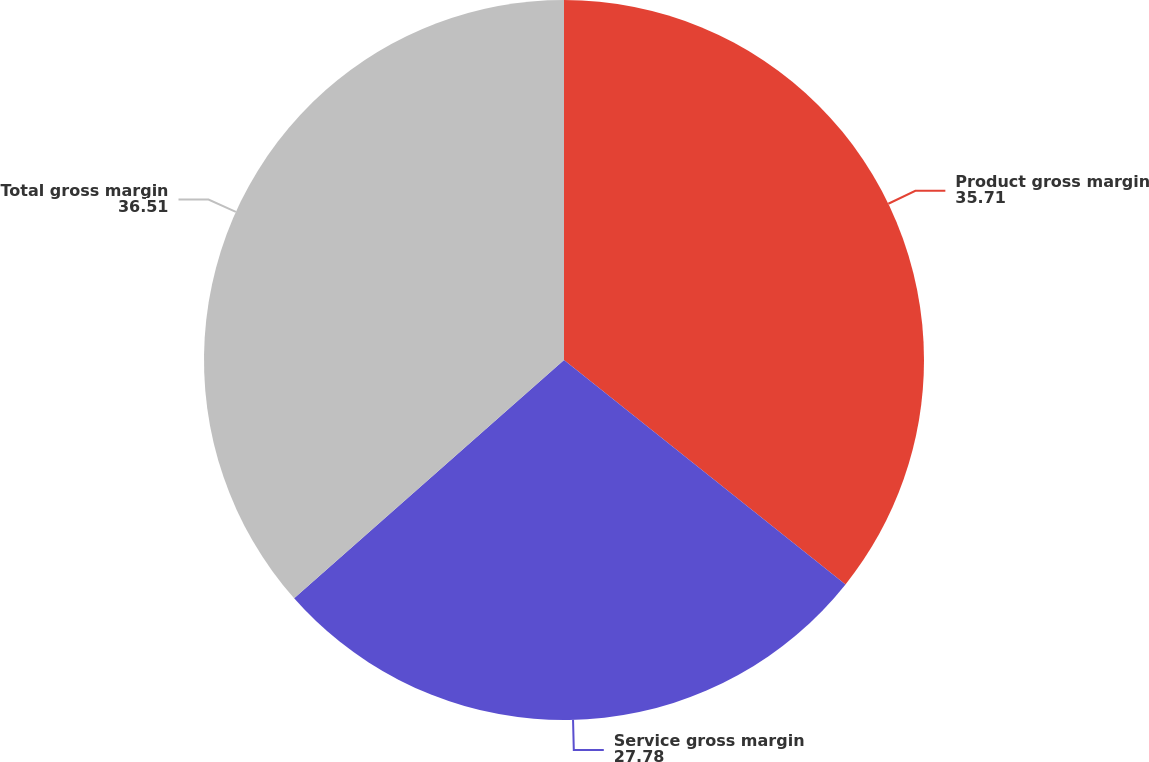Convert chart to OTSL. <chart><loc_0><loc_0><loc_500><loc_500><pie_chart><fcel>Product gross margin<fcel>Service gross margin<fcel>Total gross margin<nl><fcel>35.71%<fcel>27.78%<fcel>36.51%<nl></chart> 